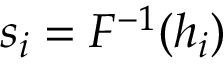Convert formula to latex. <formula><loc_0><loc_0><loc_500><loc_500>s _ { i } = F ^ { - 1 } ( h _ { i } )</formula> 